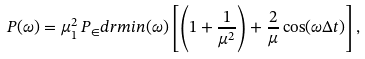<formula> <loc_0><loc_0><loc_500><loc_500>P ( \omega ) = \mu _ { 1 } ^ { 2 } \, P _ { \in } d r m { i n } ( \omega ) \left [ \left ( 1 + \frac { 1 } { \mu ^ { 2 } } \right ) + \frac { 2 } { \mu } \cos ( \omega \Delta t ) \right ] ,</formula> 